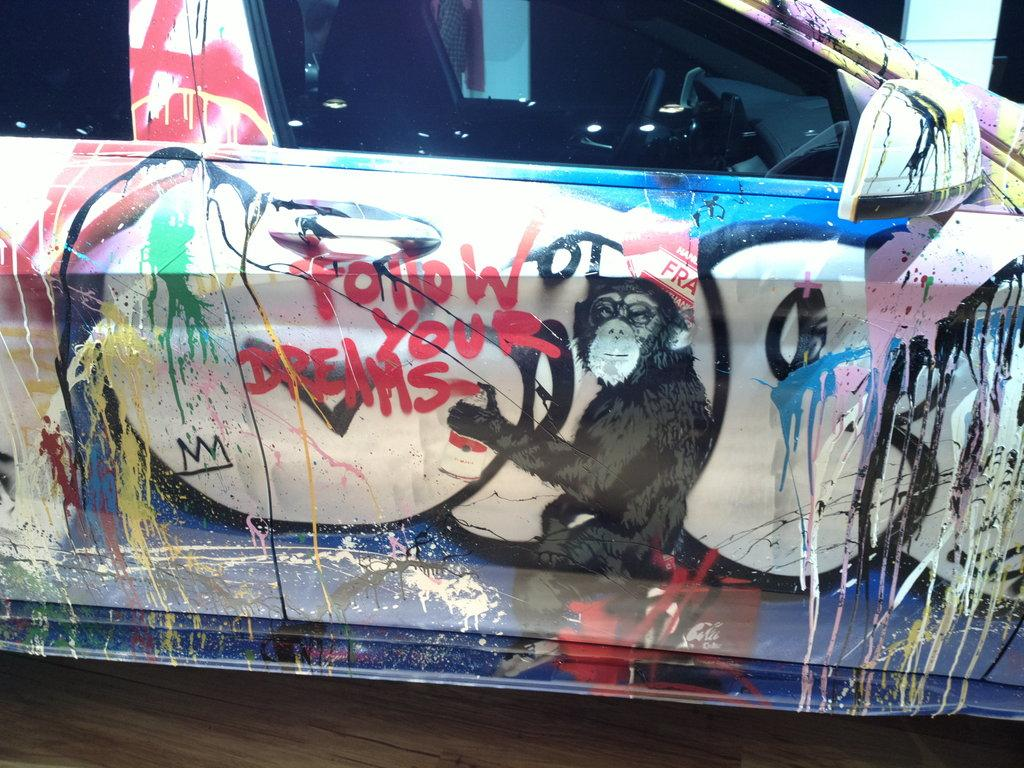What is the main subject of the image? The main subject of the image is a car. What can be observed about the appearance of the car? The car has painting on it. Are there any words or letters visible on the car? Yes, there is text visible on the car. What type of error can be seen on the car in the image? There is no error visible on the car in the image. What kind of music is the band playing in the background of the image? There is no band or music present in the image; it only features a car with painting and text. 